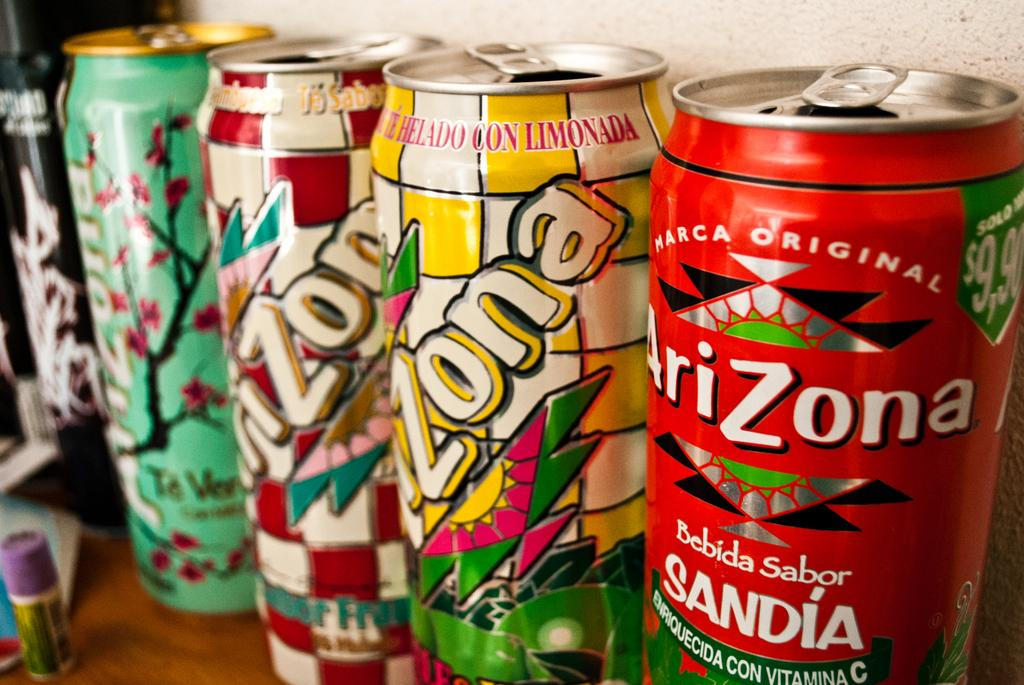<image>
Describe the image concisely. an Arizona soda can that is on a brown table 